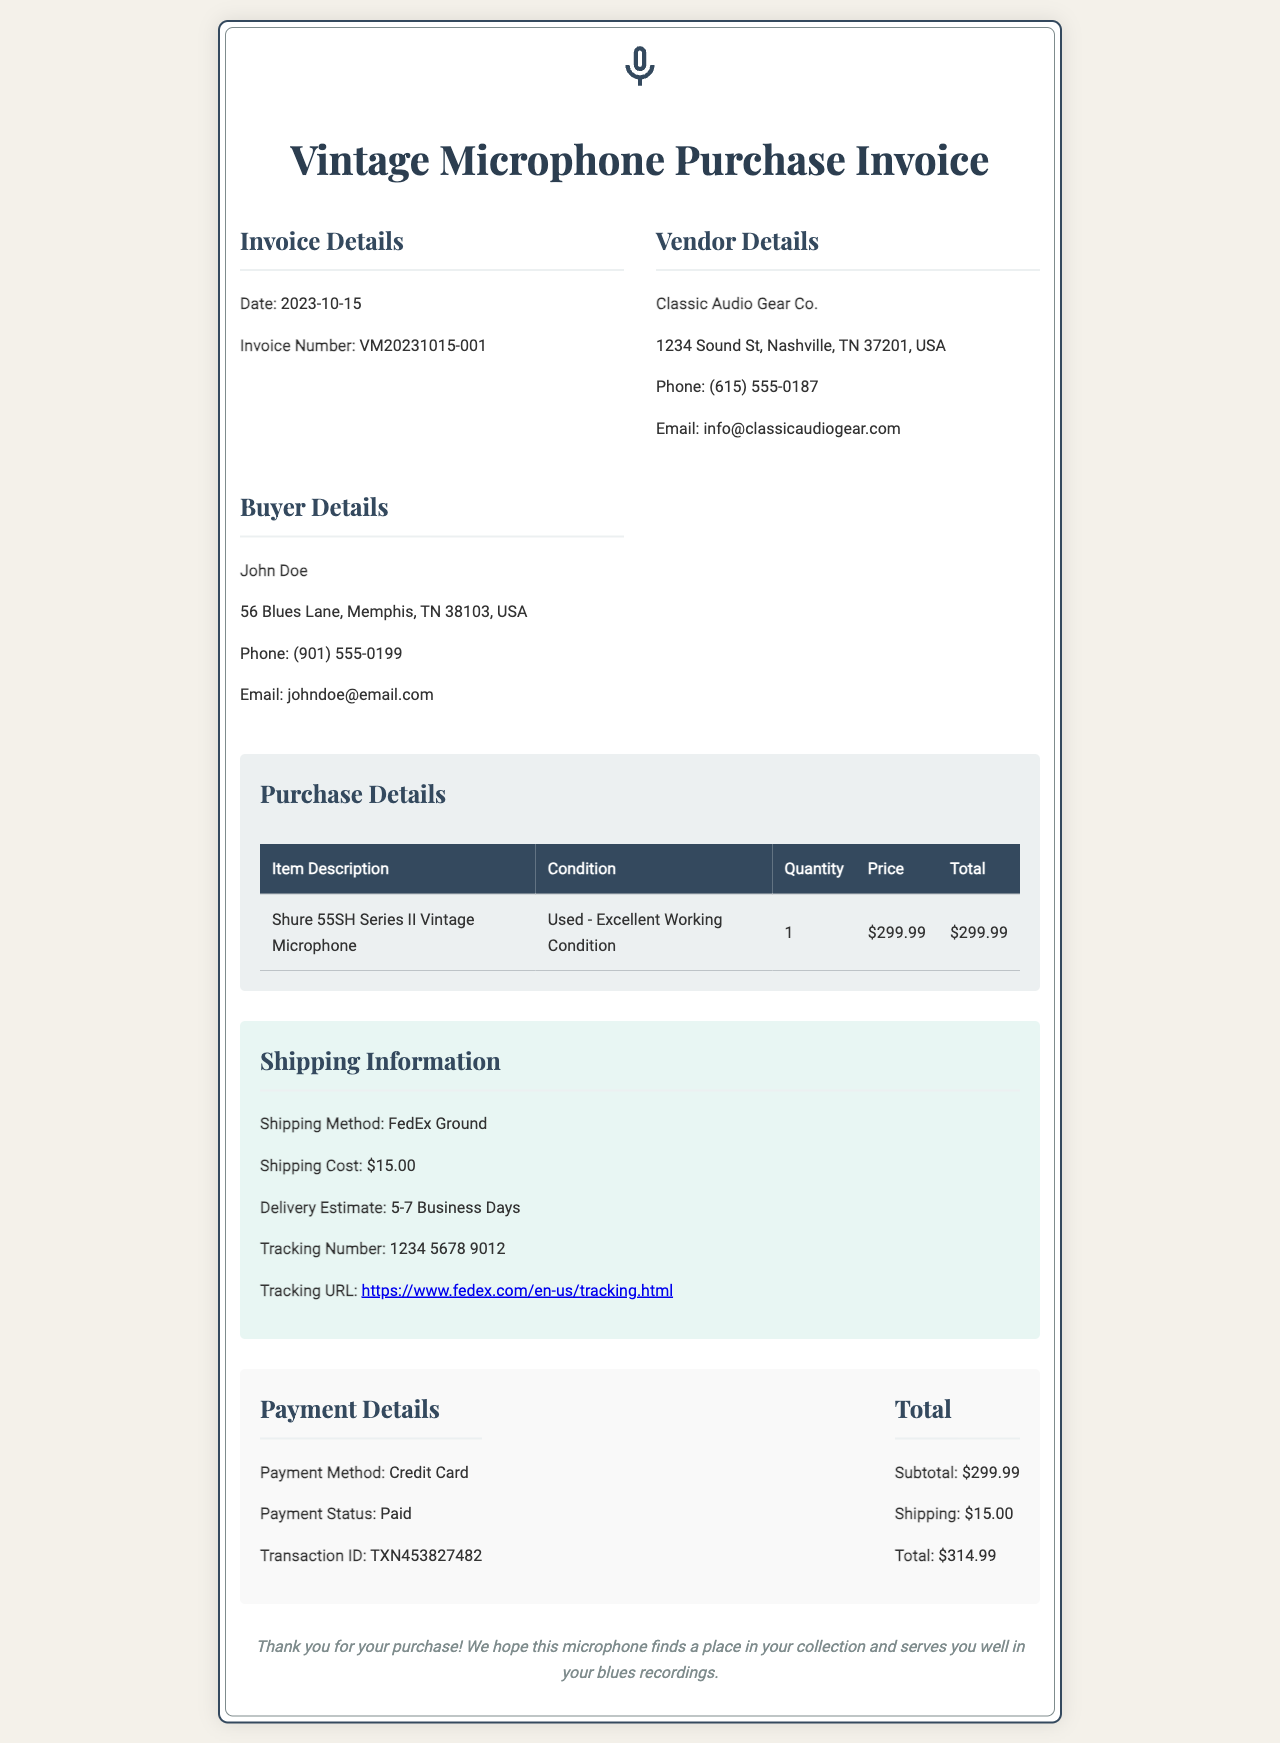What is the invoice date? The invoice date is provided in the document and specifically states '2023-10-15'.
Answer: 2023-10-15 Who is the vendor? The vendor's name, as listed in the document, is 'Classic Audio Gear Co.'.
Answer: Classic Audio Gear Co What is the shipping method? The shipping method is explicitly described in the shipping information section as 'FedEx Ground'.
Answer: FedEx Ground What is the total amount charged? The total amount is calculated from the subtotal and shipping cost listed in the payment details section, which sums to '$314.99'.
Answer: $314.99 What is the tracking number? The document includes a specific tracking number under shipping information, identified as '1234 5678 9012'.
Answer: 1234 5678 9012 How many business days is the delivery estimate? The estimated delivery timeframe in the document indicates '5-7 Business Days'.
Answer: 5-7 Business Days What is the payment method used? The document specifies the payment method used, which is 'Credit Card'.
Answer: Credit Card What condition is the vintage microphone in? The condition of the microphone is noted in the purchase details as 'Used - Excellent Working Condition'.
Answer: Used - Excellent Working Condition 